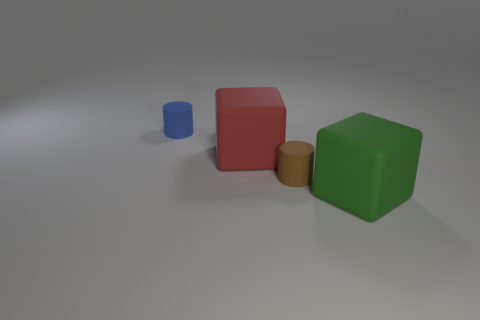Add 1 large red rubber things. How many objects exist? 5 Subtract all brown blocks. Subtract all yellow spheres. How many blocks are left? 2 Subtract 0 purple cylinders. How many objects are left? 4 Subtract all tiny blue matte objects. Subtract all small rubber objects. How many objects are left? 1 Add 2 green matte cubes. How many green matte cubes are left? 3 Add 2 large purple metallic spheres. How many large purple metallic spheres exist? 2 